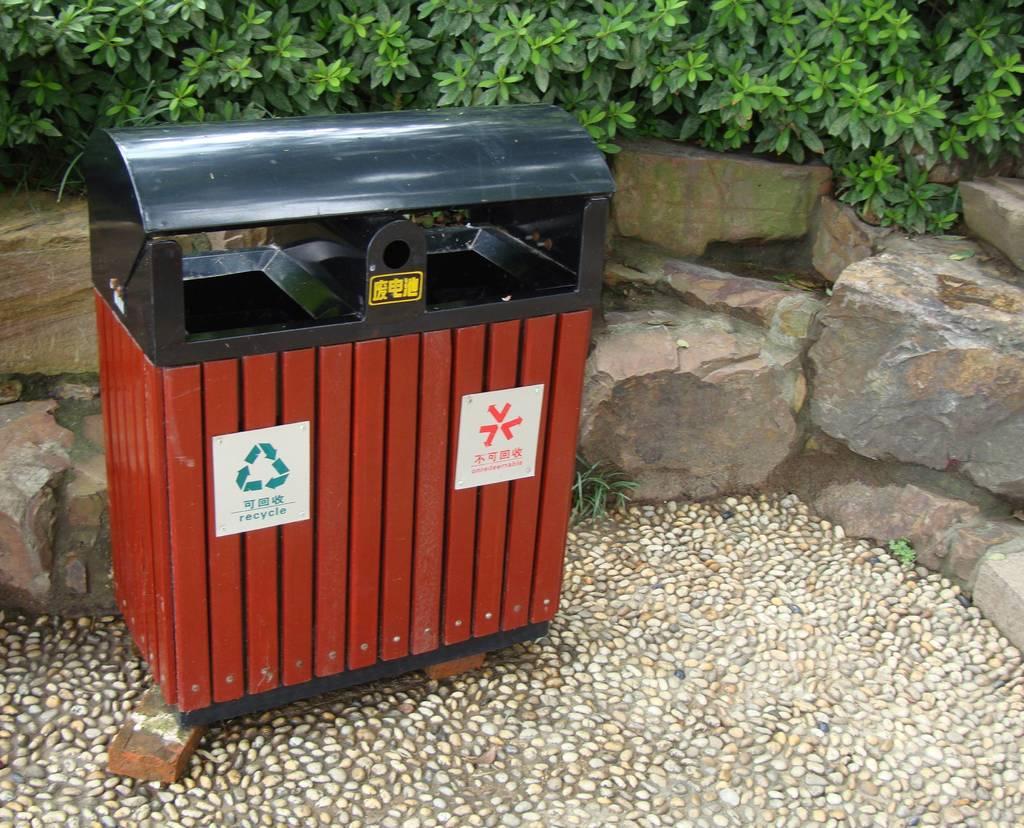What is this bin for?
Offer a very short reply. Recycle. 